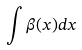Convert formula to latex. <formula><loc_0><loc_0><loc_500><loc_500>\int \beta ( x ) d x</formula> 